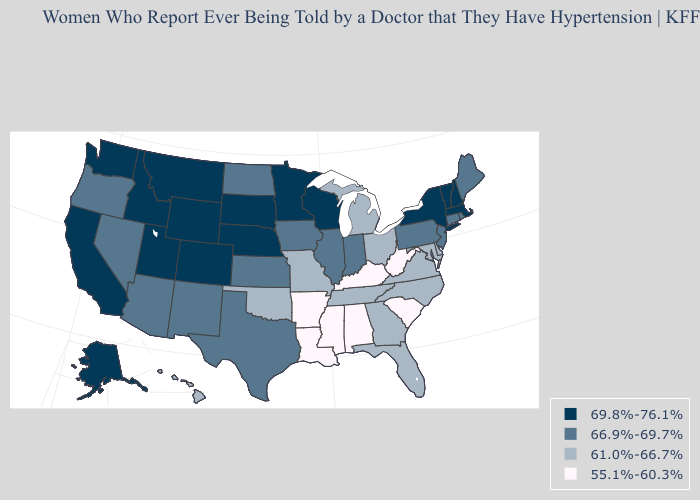What is the value of Nebraska?
Write a very short answer. 69.8%-76.1%. Does the first symbol in the legend represent the smallest category?
Be succinct. No. Name the states that have a value in the range 69.8%-76.1%?
Concise answer only. Alaska, California, Colorado, Idaho, Massachusetts, Minnesota, Montana, Nebraska, New Hampshire, New York, South Dakota, Utah, Vermont, Washington, Wisconsin, Wyoming. Name the states that have a value in the range 66.9%-69.7%?
Answer briefly. Arizona, Connecticut, Illinois, Indiana, Iowa, Kansas, Maine, Nevada, New Jersey, New Mexico, North Dakota, Oregon, Pennsylvania, Rhode Island, Texas. Name the states that have a value in the range 55.1%-60.3%?
Be succinct. Alabama, Arkansas, Kentucky, Louisiana, Mississippi, South Carolina, West Virginia. Among the states that border Louisiana , does Texas have the lowest value?
Answer briefly. No. Does New Hampshire have the lowest value in the Northeast?
Write a very short answer. No. What is the value of South Carolina?
Keep it brief. 55.1%-60.3%. Name the states that have a value in the range 69.8%-76.1%?
Concise answer only. Alaska, California, Colorado, Idaho, Massachusetts, Minnesota, Montana, Nebraska, New Hampshire, New York, South Dakota, Utah, Vermont, Washington, Wisconsin, Wyoming. Name the states that have a value in the range 66.9%-69.7%?
Keep it brief. Arizona, Connecticut, Illinois, Indiana, Iowa, Kansas, Maine, Nevada, New Jersey, New Mexico, North Dakota, Oregon, Pennsylvania, Rhode Island, Texas. Does the map have missing data?
Short answer required. No. What is the value of Illinois?
Quick response, please. 66.9%-69.7%. Does New Hampshire have the highest value in the Northeast?
Be succinct. Yes. What is the value of Wyoming?
Write a very short answer. 69.8%-76.1%. What is the highest value in the West ?
Quick response, please. 69.8%-76.1%. 